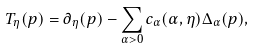Convert formula to latex. <formula><loc_0><loc_0><loc_500><loc_500>T _ { \eta } ( p ) = \partial _ { \eta } ( p ) - \sum _ { \alpha > 0 } c _ { \alpha } ( \alpha , \eta ) \Delta _ { \alpha } ( p ) ,</formula> 